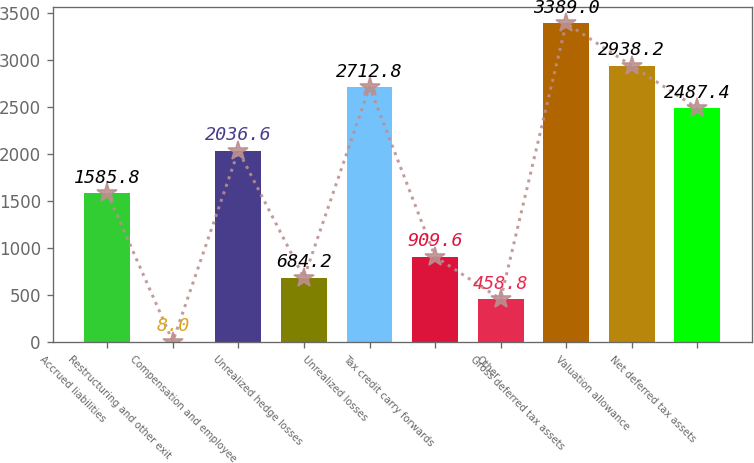Convert chart to OTSL. <chart><loc_0><loc_0><loc_500><loc_500><bar_chart><fcel>Accrued liabilities<fcel>Restructuring and other exit<fcel>Compensation and employee<fcel>Unrealized hedge losses<fcel>Unrealized losses<fcel>Tax credit carry forwards<fcel>Other<fcel>Gross deferred tax assets<fcel>Valuation allowance<fcel>Net deferred tax assets<nl><fcel>1585.8<fcel>8<fcel>2036.6<fcel>684.2<fcel>2712.8<fcel>909.6<fcel>458.8<fcel>3389<fcel>2938.2<fcel>2487.4<nl></chart> 